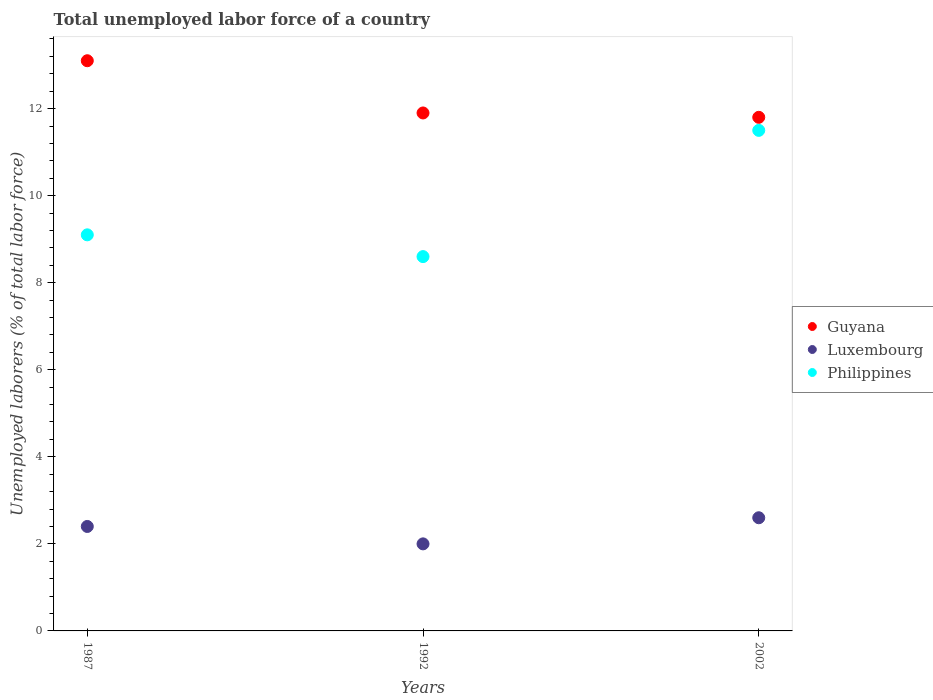How many different coloured dotlines are there?
Your answer should be very brief. 3. What is the total unemployed labor force in Philippines in 1987?
Offer a very short reply. 9.1. Across all years, what is the maximum total unemployed labor force in Luxembourg?
Make the answer very short. 2.6. Across all years, what is the minimum total unemployed labor force in Philippines?
Provide a short and direct response. 8.6. In which year was the total unemployed labor force in Philippines minimum?
Make the answer very short. 1992. What is the total total unemployed labor force in Philippines in the graph?
Ensure brevity in your answer.  29.2. What is the difference between the total unemployed labor force in Guyana in 1987 and that in 2002?
Ensure brevity in your answer.  1.3. What is the difference between the total unemployed labor force in Guyana in 2002 and the total unemployed labor force in Philippines in 1987?
Your answer should be very brief. 2.7. What is the average total unemployed labor force in Philippines per year?
Keep it short and to the point. 9.73. In the year 1992, what is the difference between the total unemployed labor force in Guyana and total unemployed labor force in Luxembourg?
Give a very brief answer. 9.9. In how many years, is the total unemployed labor force in Luxembourg greater than 12.8 %?
Your answer should be compact. 0. What is the ratio of the total unemployed labor force in Philippines in 1987 to that in 2002?
Provide a short and direct response. 0.79. Is the total unemployed labor force in Luxembourg in 1987 less than that in 1992?
Ensure brevity in your answer.  No. Is the difference between the total unemployed labor force in Guyana in 1987 and 1992 greater than the difference between the total unemployed labor force in Luxembourg in 1987 and 1992?
Offer a very short reply. Yes. What is the difference between the highest and the second highest total unemployed labor force in Luxembourg?
Your answer should be compact. 0.2. What is the difference between the highest and the lowest total unemployed labor force in Luxembourg?
Keep it short and to the point. 0.6. In how many years, is the total unemployed labor force in Guyana greater than the average total unemployed labor force in Guyana taken over all years?
Provide a succinct answer. 1. Is the total unemployed labor force in Luxembourg strictly less than the total unemployed labor force in Guyana over the years?
Give a very brief answer. Yes. How many dotlines are there?
Your answer should be very brief. 3. How many years are there in the graph?
Make the answer very short. 3. Does the graph contain grids?
Your response must be concise. No. How many legend labels are there?
Your response must be concise. 3. What is the title of the graph?
Offer a terse response. Total unemployed labor force of a country. What is the label or title of the Y-axis?
Ensure brevity in your answer.  Unemployed laborers (% of total labor force). What is the Unemployed laborers (% of total labor force) in Guyana in 1987?
Keep it short and to the point. 13.1. What is the Unemployed laborers (% of total labor force) in Luxembourg in 1987?
Your response must be concise. 2.4. What is the Unemployed laborers (% of total labor force) of Philippines in 1987?
Offer a terse response. 9.1. What is the Unemployed laborers (% of total labor force) in Guyana in 1992?
Your response must be concise. 11.9. What is the Unemployed laborers (% of total labor force) in Philippines in 1992?
Keep it short and to the point. 8.6. What is the Unemployed laborers (% of total labor force) in Guyana in 2002?
Keep it short and to the point. 11.8. What is the Unemployed laborers (% of total labor force) of Luxembourg in 2002?
Provide a succinct answer. 2.6. Across all years, what is the maximum Unemployed laborers (% of total labor force) in Guyana?
Provide a short and direct response. 13.1. Across all years, what is the maximum Unemployed laborers (% of total labor force) of Luxembourg?
Offer a very short reply. 2.6. Across all years, what is the maximum Unemployed laborers (% of total labor force) of Philippines?
Your answer should be very brief. 11.5. Across all years, what is the minimum Unemployed laborers (% of total labor force) of Guyana?
Give a very brief answer. 11.8. Across all years, what is the minimum Unemployed laborers (% of total labor force) in Luxembourg?
Offer a very short reply. 2. Across all years, what is the minimum Unemployed laborers (% of total labor force) in Philippines?
Your answer should be very brief. 8.6. What is the total Unemployed laborers (% of total labor force) of Guyana in the graph?
Provide a short and direct response. 36.8. What is the total Unemployed laborers (% of total labor force) in Luxembourg in the graph?
Your response must be concise. 7. What is the total Unemployed laborers (% of total labor force) of Philippines in the graph?
Give a very brief answer. 29.2. What is the difference between the Unemployed laborers (% of total labor force) of Guyana in 1987 and that in 1992?
Your response must be concise. 1.2. What is the difference between the Unemployed laborers (% of total labor force) of Philippines in 1987 and that in 1992?
Offer a terse response. 0.5. What is the difference between the Unemployed laborers (% of total labor force) of Guyana in 1992 and that in 2002?
Offer a terse response. 0.1. What is the difference between the Unemployed laborers (% of total labor force) of Philippines in 1992 and that in 2002?
Offer a very short reply. -2.9. What is the difference between the Unemployed laborers (% of total labor force) of Guyana in 1987 and the Unemployed laborers (% of total labor force) of Philippines in 1992?
Offer a very short reply. 4.5. What is the difference between the Unemployed laborers (% of total labor force) of Guyana in 1987 and the Unemployed laborers (% of total labor force) of Luxembourg in 2002?
Offer a very short reply. 10.5. What is the difference between the Unemployed laborers (% of total labor force) in Guyana in 1987 and the Unemployed laborers (% of total labor force) in Philippines in 2002?
Provide a succinct answer. 1.6. What is the difference between the Unemployed laborers (% of total labor force) in Luxembourg in 1987 and the Unemployed laborers (% of total labor force) in Philippines in 2002?
Offer a terse response. -9.1. What is the average Unemployed laborers (% of total labor force) of Guyana per year?
Offer a very short reply. 12.27. What is the average Unemployed laborers (% of total labor force) in Luxembourg per year?
Provide a short and direct response. 2.33. What is the average Unemployed laborers (% of total labor force) of Philippines per year?
Offer a terse response. 9.73. In the year 1987, what is the difference between the Unemployed laborers (% of total labor force) in Guyana and Unemployed laborers (% of total labor force) in Philippines?
Keep it short and to the point. 4. In the year 1987, what is the difference between the Unemployed laborers (% of total labor force) of Luxembourg and Unemployed laborers (% of total labor force) of Philippines?
Ensure brevity in your answer.  -6.7. In the year 1992, what is the difference between the Unemployed laborers (% of total labor force) in Guyana and Unemployed laborers (% of total labor force) in Luxembourg?
Ensure brevity in your answer.  9.9. In the year 1992, what is the difference between the Unemployed laborers (% of total labor force) in Guyana and Unemployed laborers (% of total labor force) in Philippines?
Your answer should be compact. 3.3. In the year 2002, what is the difference between the Unemployed laborers (% of total labor force) of Guyana and Unemployed laborers (% of total labor force) of Philippines?
Provide a succinct answer. 0.3. In the year 2002, what is the difference between the Unemployed laborers (% of total labor force) of Luxembourg and Unemployed laborers (% of total labor force) of Philippines?
Your answer should be compact. -8.9. What is the ratio of the Unemployed laborers (% of total labor force) of Guyana in 1987 to that in 1992?
Your answer should be very brief. 1.1. What is the ratio of the Unemployed laborers (% of total labor force) of Luxembourg in 1987 to that in 1992?
Give a very brief answer. 1.2. What is the ratio of the Unemployed laborers (% of total labor force) of Philippines in 1987 to that in 1992?
Offer a terse response. 1.06. What is the ratio of the Unemployed laborers (% of total labor force) of Guyana in 1987 to that in 2002?
Your answer should be compact. 1.11. What is the ratio of the Unemployed laborers (% of total labor force) of Luxembourg in 1987 to that in 2002?
Your answer should be compact. 0.92. What is the ratio of the Unemployed laborers (% of total labor force) in Philippines in 1987 to that in 2002?
Your response must be concise. 0.79. What is the ratio of the Unemployed laborers (% of total labor force) of Guyana in 1992 to that in 2002?
Your answer should be compact. 1.01. What is the ratio of the Unemployed laborers (% of total labor force) in Luxembourg in 1992 to that in 2002?
Offer a very short reply. 0.77. What is the ratio of the Unemployed laborers (% of total labor force) of Philippines in 1992 to that in 2002?
Offer a very short reply. 0.75. What is the difference between the highest and the second highest Unemployed laborers (% of total labor force) of Guyana?
Give a very brief answer. 1.2. What is the difference between the highest and the second highest Unemployed laborers (% of total labor force) of Philippines?
Offer a terse response. 2.4. What is the difference between the highest and the lowest Unemployed laborers (% of total labor force) of Philippines?
Your answer should be very brief. 2.9. 